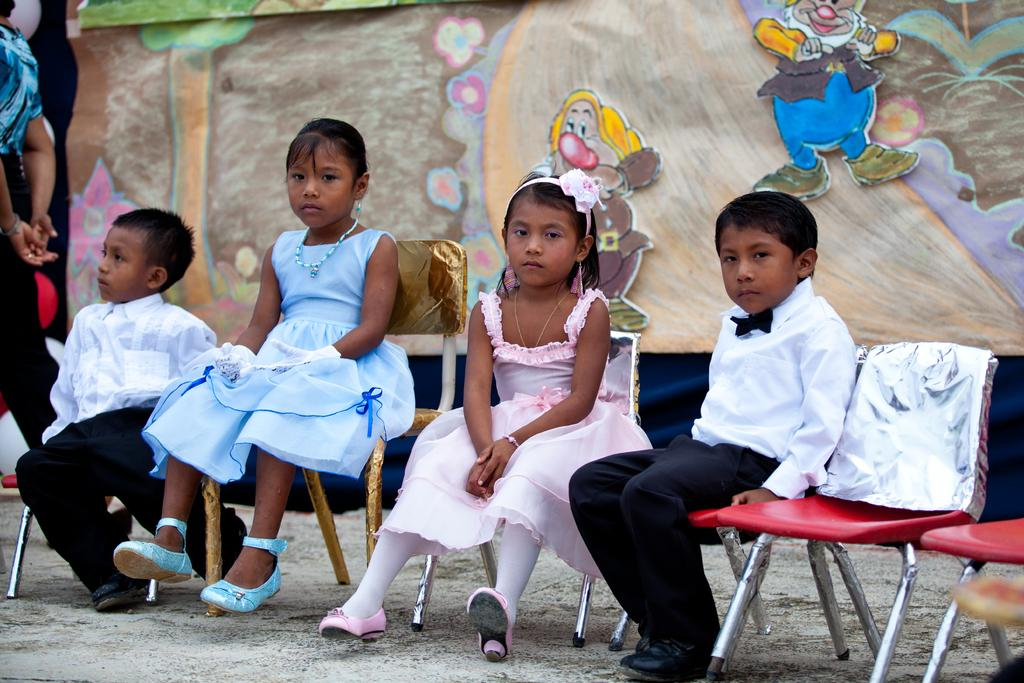How many people are sitting in the image? There are four people sitting on chairs in the image. What can be seen in the background of the image? There is a painting of a tree in the background of the image. What word is being spelled out by the people in the image? There is no indication in the image that the people are spelling out a word. 